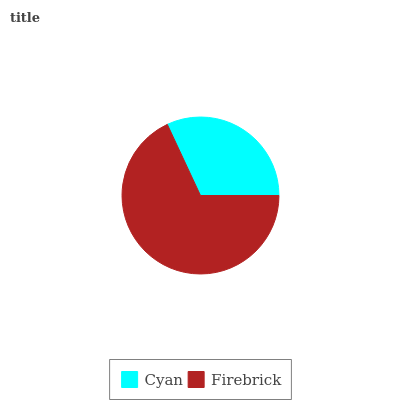Is Cyan the minimum?
Answer yes or no. Yes. Is Firebrick the maximum?
Answer yes or no. Yes. Is Firebrick the minimum?
Answer yes or no. No. Is Firebrick greater than Cyan?
Answer yes or no. Yes. Is Cyan less than Firebrick?
Answer yes or no. Yes. Is Cyan greater than Firebrick?
Answer yes or no. No. Is Firebrick less than Cyan?
Answer yes or no. No. Is Firebrick the high median?
Answer yes or no. Yes. Is Cyan the low median?
Answer yes or no. Yes. Is Cyan the high median?
Answer yes or no. No. Is Firebrick the low median?
Answer yes or no. No. 